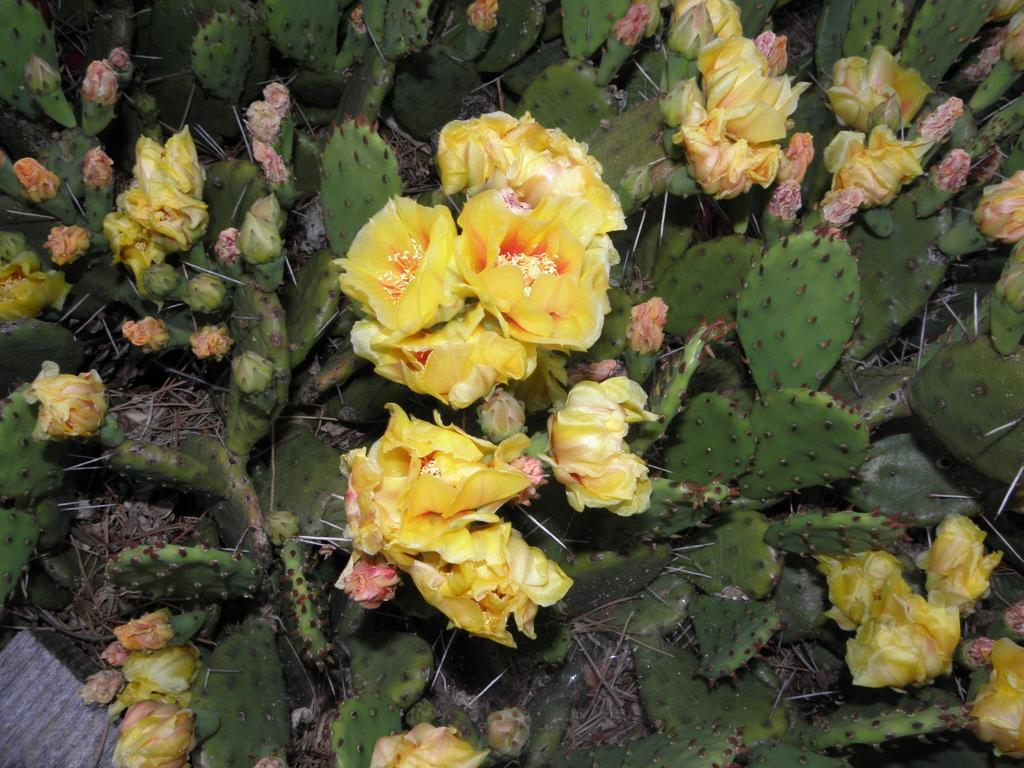What types of vegetation are present in the image? The image contains flowers and plants. What else can be seen in the image besides vegetation? There are also twigs visible in the image. Where is the wooden object located in the image? The wooden object is in the bottom left corner of the image. How many connections can be seen between the flowers and the wooden object in the image? There is no mention of connections between the flowers and the wooden object in the image, so it cannot be determined from the facts provided. 